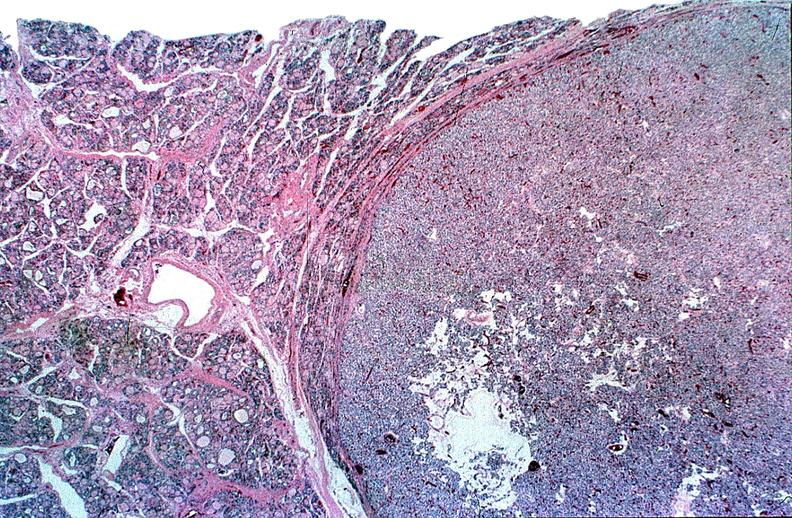what does this image show?
Answer the question using a single word or phrase. Thyroid 